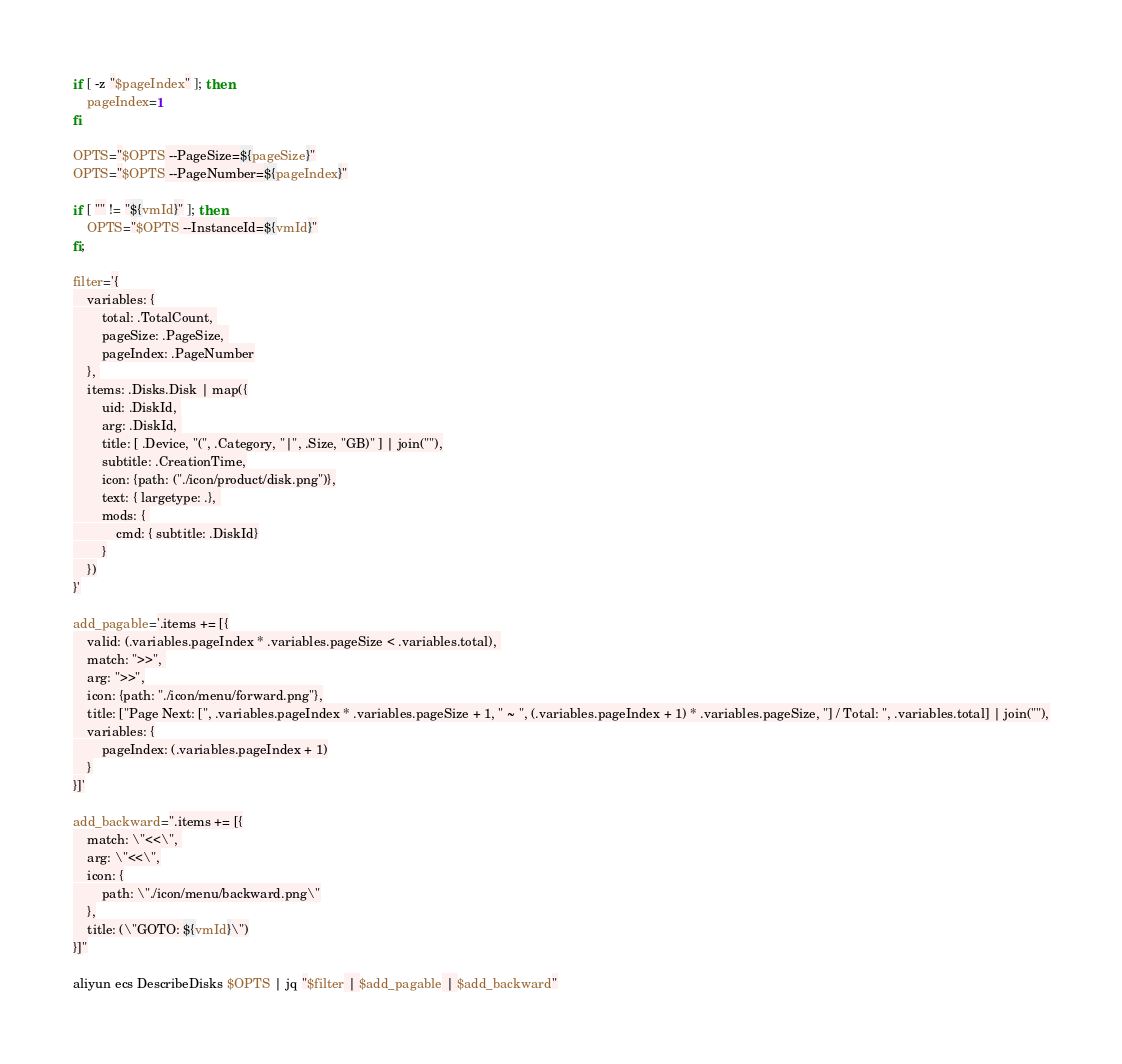Convert code to text. <code><loc_0><loc_0><loc_500><loc_500><_Bash_>if [ -z "$pageIndex" ]; then
    pageIndex=1
fi

OPTS="$OPTS --PageSize=${pageSize}"
OPTS="$OPTS --PageNumber=${pageIndex}"

if [ "" != "${vmId}" ]; then
	OPTS="$OPTS --InstanceId=${vmId}"
fi;

filter='{
	variables: {
		total: .TotalCount, 
		pageSize: .PageSize, 
		pageIndex: .PageNumber
	}, 
	items: .Disks.Disk | map({
		uid: .DiskId, 
		arg: .DiskId, 
		title: [ .Device, "(", .Category, "|", .Size, "GB)" ] | join(""),
		subtitle: .CreationTime,
		icon: {path: ("./icon/product/disk.png")},
		text: { largetype: .}, 
		mods: { 
			cmd: { subtitle: .DiskId}
		}
	})
}'

add_pagable='.items += [{
	valid: (.variables.pageIndex * .variables.pageSize < .variables.total), 
	match: ">>", 
	arg: ">>",
	icon: {path: "./icon/menu/forward.png"},
	title: ["Page Next: [", .variables.pageIndex * .variables.pageSize + 1, " ~ ", (.variables.pageIndex + 1) * .variables.pageSize, "] / Total: ", .variables.total] | join(""),
	variables: {
		pageIndex: (.variables.pageIndex + 1)
	}
}]'

add_backward=".items += [{
	match: \"<<\", 
	arg: \"<<\",
	icon: {
		path: \"./icon/menu/backward.png\"
	},
	title: (\"GOTO: ${vmId}\")
}]"

aliyun ecs DescribeDisks $OPTS | jq "$filter | $add_pagable | $add_backward"</code> 